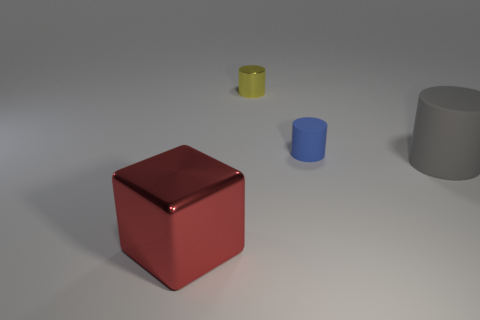What material is the object in front of the large thing to the right of the big red block? The object appears to be a cylindrical metal canister, characterized by its reflective surface and the typical properties associated with metals, such as luster and conductivity. 